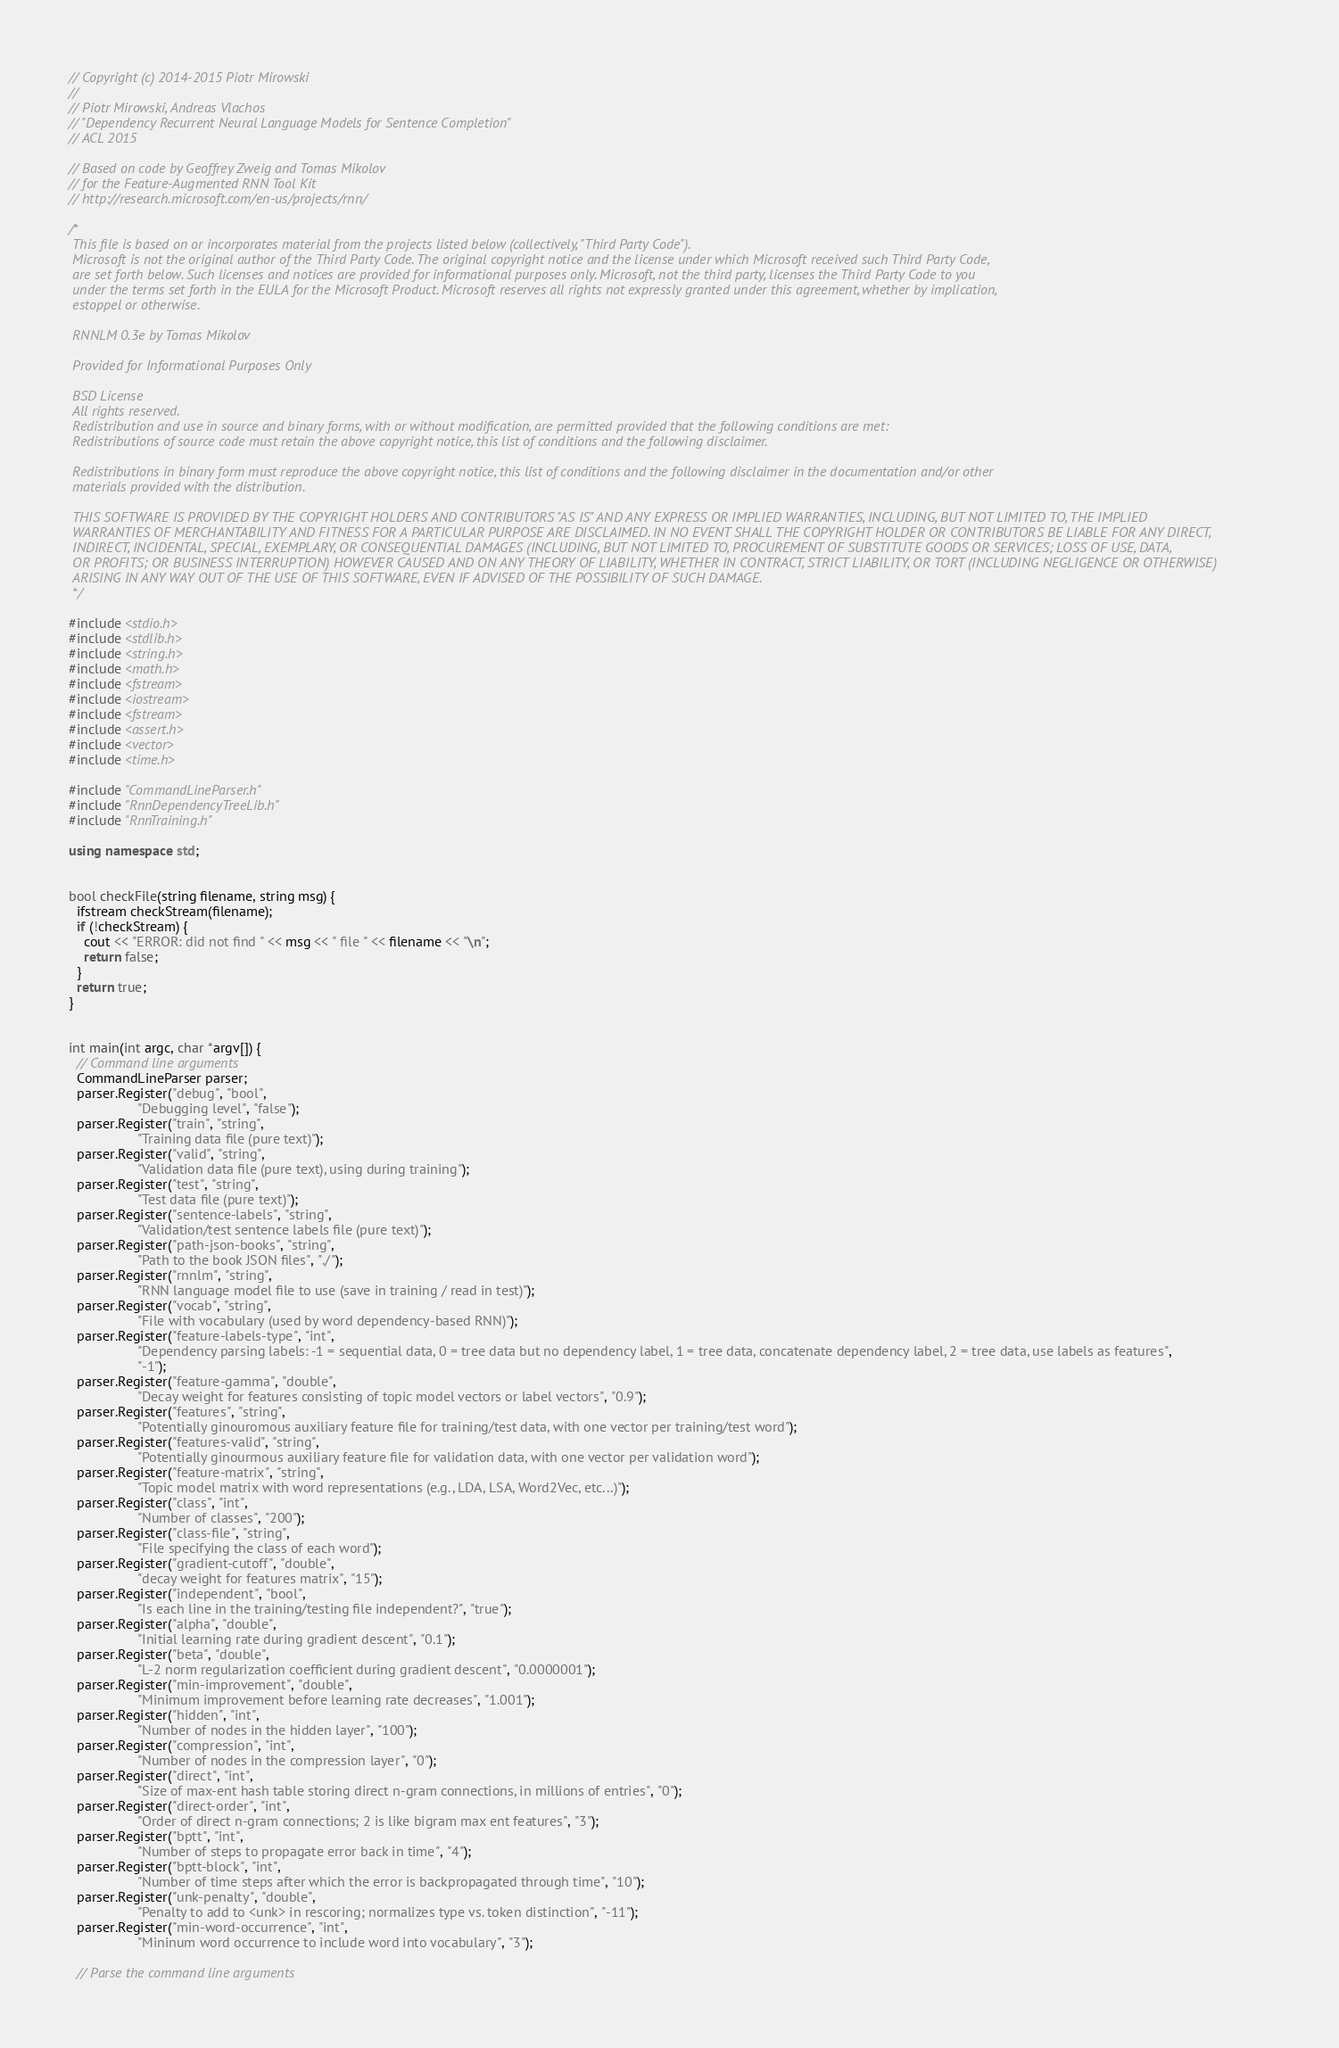<code> <loc_0><loc_0><loc_500><loc_500><_C++_>// Copyright (c) 2014-2015 Piotr Mirowski
//
// Piotr Mirowski, Andreas Vlachos
// "Dependency Recurrent Neural Language Models for Sentence Completion"
// ACL 2015

// Based on code by Geoffrey Zweig and Tomas Mikolov
// for the Feature-Augmented RNN Tool Kit
// http://research.microsoft.com/en-us/projects/rnn/

/*
 This file is based on or incorporates material from the projects listed below (collectively, "Third Party Code").
 Microsoft is not the original author of the Third Party Code. The original copyright notice and the license under which Microsoft received such Third Party Code,
 are set forth below. Such licenses and notices are provided for informational purposes only. Microsoft, not the third party, licenses the Third Party Code to you
 under the terms set forth in the EULA for the Microsoft Product. Microsoft reserves all rights not expressly granted under this agreement, whether by implication,
 estoppel or otherwise.

 RNNLM 0.3e by Tomas Mikolov

 Provided for Informational Purposes Only

 BSD License
 All rights reserved.
 Redistribution and use in source and binary forms, with or without modification, are permitted provided that the following conditions are met:
 Redistributions of source code must retain the above copyright notice, this list of conditions and the following disclaimer.

 Redistributions in binary form must reproduce the above copyright notice, this list of conditions and the following disclaimer in the documentation and/or other
 materials provided with the distribution.

 THIS SOFTWARE IS PROVIDED BY THE COPYRIGHT HOLDERS AND CONTRIBUTORS "AS IS" AND ANY EXPRESS OR IMPLIED WARRANTIES, INCLUDING, BUT NOT LIMITED TO, THE IMPLIED
 WARRANTIES OF MERCHANTABILITY AND FITNESS FOR A PARTICULAR PURPOSE ARE DISCLAIMED. IN NO EVENT SHALL THE COPYRIGHT HOLDER OR CONTRIBUTORS BE LIABLE FOR ANY DIRECT,
 INDIRECT, INCIDENTAL, SPECIAL, EXEMPLARY, OR CONSEQUENTIAL DAMAGES (INCLUDING, BUT NOT LIMITED TO, PROCUREMENT OF SUBSTITUTE GOODS OR SERVICES; LOSS OF USE, DATA,
 OR PROFITS; OR BUSINESS INTERRUPTION) HOWEVER CAUSED AND ON ANY THEORY OF LIABILITY, WHETHER IN CONTRACT, STRICT LIABILITY, OR TORT (INCLUDING NEGLIGENCE OR OTHERWISE)
 ARISING IN ANY WAY OUT OF THE USE OF THIS SOFTWARE, EVEN IF ADVISED OF THE POSSIBILITY OF SUCH DAMAGE.
 */

#include <stdio.h>
#include <stdlib.h>
#include <string.h>
#include <math.h>
#include <fstream>
#include <iostream>
#include <fstream>
#include <assert.h>
#include <vector>
#include <time.h>

#include "CommandLineParser.h"
#include "RnnDependencyTreeLib.h"
#include "RnnTraining.h"

using namespace std;


bool checkFile(string filename, string msg) {
  ifstream checkStream(filename);
  if (!checkStream) {
    cout << "ERROR: did not find " << msg << " file " << filename << "\n";
    return false;
  }
  return true;
}


int main(int argc, char *argv[]) {
  // Command line arguments
  CommandLineParser parser;
  parser.Register("debug", "bool",
                  "Debugging level", "false");
  parser.Register("train", "string",
                  "Training data file (pure text)");
  parser.Register("valid", "string",
                  "Validation data file (pure text), using during training");
  parser.Register("test", "string",
                  "Test data file (pure text)");
  parser.Register("sentence-labels", "string",
                  "Validation/test sentence labels file (pure text)");
  parser.Register("path-json-books", "string",
                  "Path to the book JSON files", "./");
  parser.Register("rnnlm", "string",
                  "RNN language model file to use (save in training / read in test)");
  parser.Register("vocab", "string",
                  "File with vocabulary (used by word dependency-based RNN)");
  parser.Register("feature-labels-type", "int",
                  "Dependency parsing labels: -1 = sequential data, 0 = tree data but no dependency label, 1 = tree data, concatenate dependency label, 2 = tree data, use labels as features",
                  "-1");
  parser.Register("feature-gamma", "double",
                  "Decay weight for features consisting of topic model vectors or label vectors", "0.9");
  parser.Register("features", "string",
                  "Potentially ginouromous auxiliary feature file for training/test data, with one vector per training/test word");
  parser.Register("features-valid", "string",
                  "Potentially ginourmous auxiliary feature file for validation data, with one vector per validation word");
  parser.Register("feature-matrix", "string",
                  "Topic model matrix with word representations (e.g., LDA, LSA, Word2Vec, etc...)");
  parser.Register("class", "int",
                  "Number of classes", "200");
  parser.Register("class-file", "string",
                  "File specifying the class of each word");
  parser.Register("gradient-cutoff", "double",
                  "decay weight for features matrix", "15");
  parser.Register("independent", "bool",
                  "Is each line in the training/testing file independent?", "true");
  parser.Register("alpha", "double",
                  "Initial learning rate during gradient descent", "0.1");
  parser.Register("beta", "double",
                  "L-2 norm regularization coefficient during gradient descent", "0.0000001");
  parser.Register("min-improvement", "double",
                  "Minimum improvement before learning rate decreases", "1.001");
  parser.Register("hidden", "int",
                  "Number of nodes in the hidden layer", "100");
  parser.Register("compression", "int",
                  "Number of nodes in the compression layer", "0");
  parser.Register("direct", "int",
                  "Size of max-ent hash table storing direct n-gram connections, in millions of entries", "0");
  parser.Register("direct-order", "int",
                  "Order of direct n-gram connections; 2 is like bigram max ent features", "3");
  parser.Register("bptt", "int",
                  "Number of steps to propagate error back in time", "4");
  parser.Register("bptt-block", "int",
                  "Number of time steps after which the error is backpropagated through time", "10");
  parser.Register("unk-penalty", "double",
                  "Penalty to add to <unk> in rescoring; normalizes type vs. token distinction", "-11");
  parser.Register("min-word-occurrence", "int",
                  "Mininum word occurrence to include word into vocabulary", "3");
  
  // Parse the command line arguments</code> 